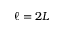<formula> <loc_0><loc_0><loc_500><loc_500>\ell = 2 L</formula> 